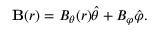Convert formula to latex. <formula><loc_0><loc_0><loc_500><loc_500>B ( r ) = B _ { \theta } ( r ) \hat { \theta } + B _ { \varphi } \hat { \varphi } .</formula> 